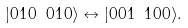<formula> <loc_0><loc_0><loc_500><loc_500>| 0 1 0 \ 0 1 0 \rangle \leftrightarrow | 0 0 1 \ 1 0 0 \rangle .</formula> 